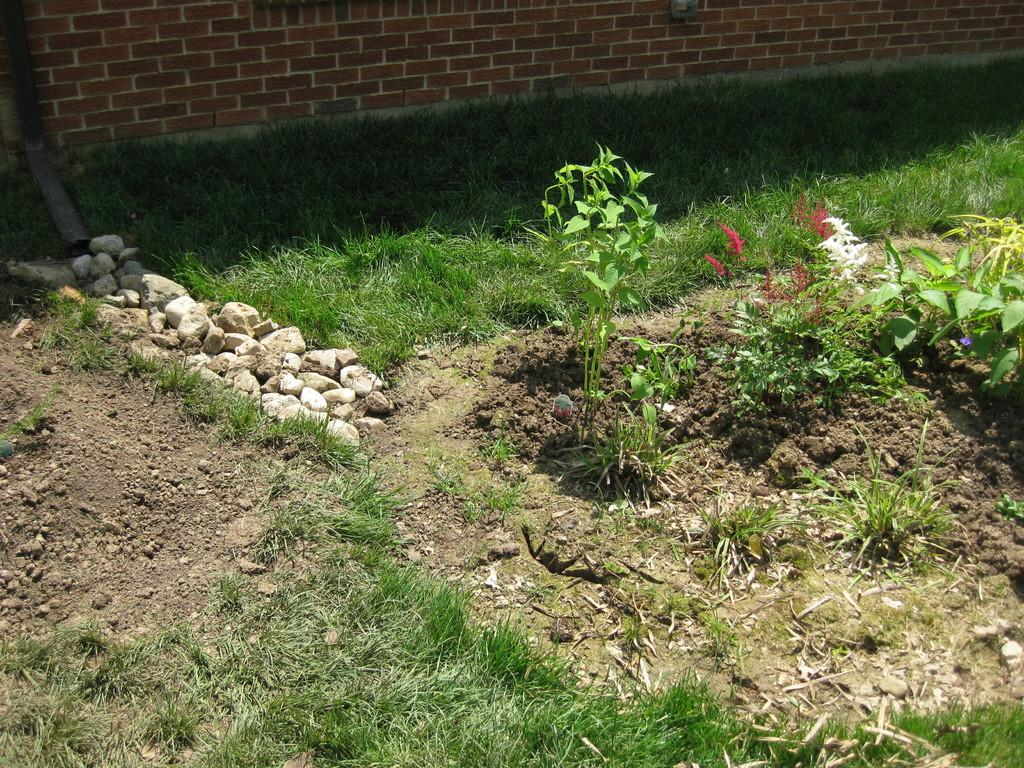What type of vegetation can be seen in the image? There is grass and plants with flowers in the image. What can be found on the ground in the image? There are stones on the ground in the image. What type of structure is visible in the image? There is a brick wall in the image. Can you see a hydrant in the image? There is no hydrant present in the image. Is there an alarm going off in the image? There is no alarm present in the image. 